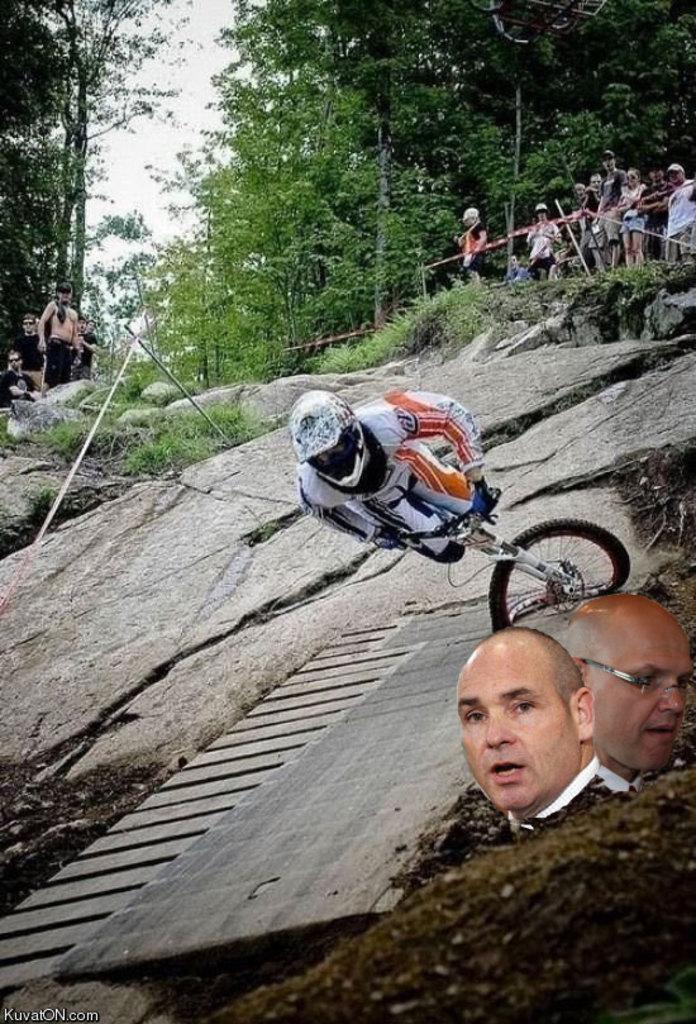Could you give a brief overview of what you see in this image? In this image i can see the mountain and right side i can see there are the group of persons standing on the rock and there are the trees visible on the back ground and a person riding on a bi cycle on the mountain and two person's picture is visible on the right side. 